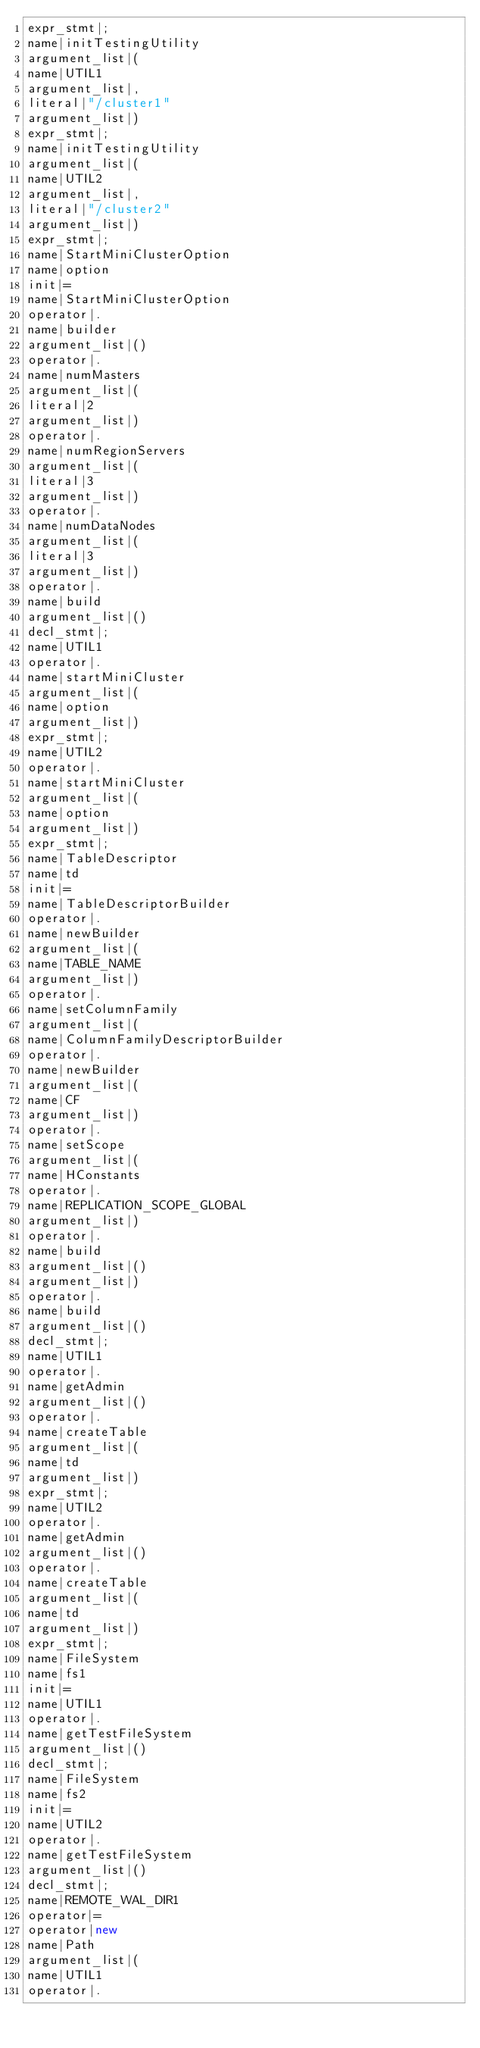Convert code to text. <code><loc_0><loc_0><loc_500><loc_500><_Java_>expr_stmt|;
name|initTestingUtility
argument_list|(
name|UTIL1
argument_list|,
literal|"/cluster1"
argument_list|)
expr_stmt|;
name|initTestingUtility
argument_list|(
name|UTIL2
argument_list|,
literal|"/cluster2"
argument_list|)
expr_stmt|;
name|StartMiniClusterOption
name|option
init|=
name|StartMiniClusterOption
operator|.
name|builder
argument_list|()
operator|.
name|numMasters
argument_list|(
literal|2
argument_list|)
operator|.
name|numRegionServers
argument_list|(
literal|3
argument_list|)
operator|.
name|numDataNodes
argument_list|(
literal|3
argument_list|)
operator|.
name|build
argument_list|()
decl_stmt|;
name|UTIL1
operator|.
name|startMiniCluster
argument_list|(
name|option
argument_list|)
expr_stmt|;
name|UTIL2
operator|.
name|startMiniCluster
argument_list|(
name|option
argument_list|)
expr_stmt|;
name|TableDescriptor
name|td
init|=
name|TableDescriptorBuilder
operator|.
name|newBuilder
argument_list|(
name|TABLE_NAME
argument_list|)
operator|.
name|setColumnFamily
argument_list|(
name|ColumnFamilyDescriptorBuilder
operator|.
name|newBuilder
argument_list|(
name|CF
argument_list|)
operator|.
name|setScope
argument_list|(
name|HConstants
operator|.
name|REPLICATION_SCOPE_GLOBAL
argument_list|)
operator|.
name|build
argument_list|()
argument_list|)
operator|.
name|build
argument_list|()
decl_stmt|;
name|UTIL1
operator|.
name|getAdmin
argument_list|()
operator|.
name|createTable
argument_list|(
name|td
argument_list|)
expr_stmt|;
name|UTIL2
operator|.
name|getAdmin
argument_list|()
operator|.
name|createTable
argument_list|(
name|td
argument_list|)
expr_stmt|;
name|FileSystem
name|fs1
init|=
name|UTIL1
operator|.
name|getTestFileSystem
argument_list|()
decl_stmt|;
name|FileSystem
name|fs2
init|=
name|UTIL2
operator|.
name|getTestFileSystem
argument_list|()
decl_stmt|;
name|REMOTE_WAL_DIR1
operator|=
operator|new
name|Path
argument_list|(
name|UTIL1
operator|.</code> 